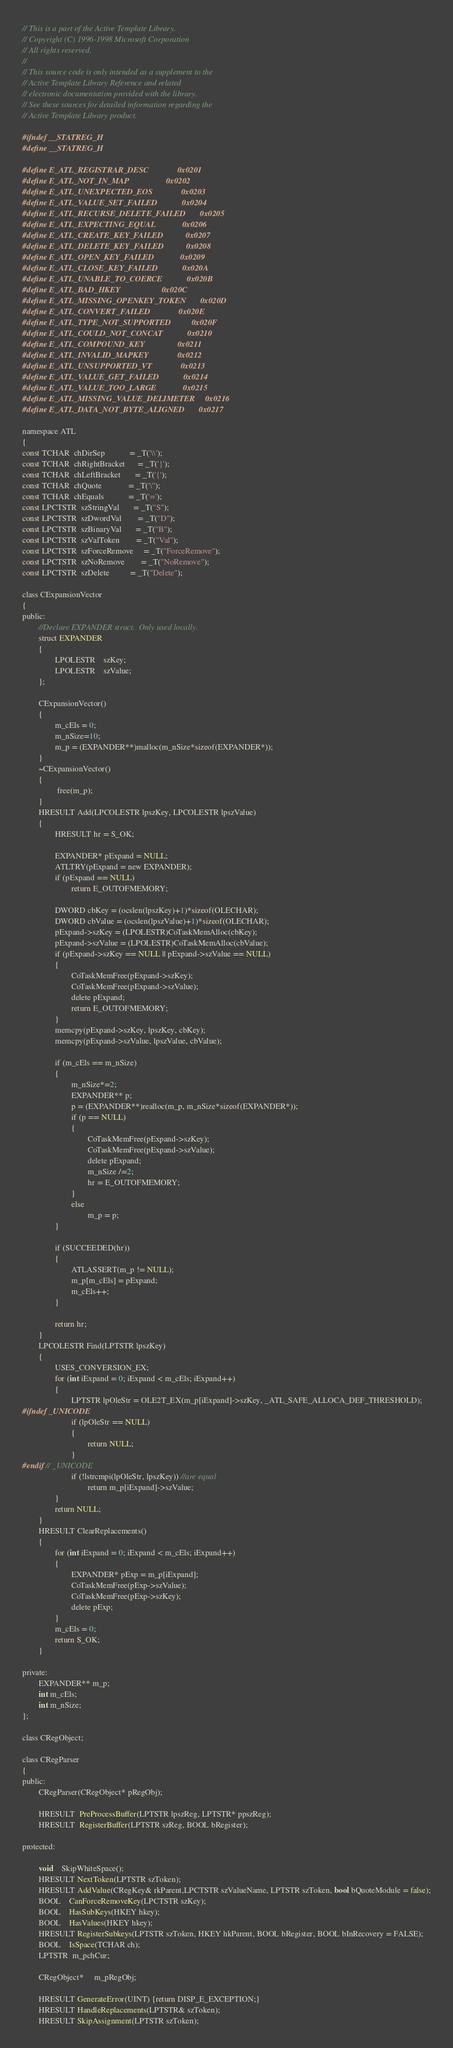Convert code to text. <code><loc_0><loc_0><loc_500><loc_500><_C_>// This is a part of the Active Template Library.
// Copyright (C) 1996-1998 Microsoft Corporation
// All rights reserved.
//
// This source code is only intended as a supplement to the
// Active Template Library Reference and related
// electronic documentation provided with the library.
// See these sources for detailed information regarding the
// Active Template Library product.

#ifndef __STATREG_H
#define __STATREG_H

#define E_ATL_REGISTRAR_DESC              0x0201
#define E_ATL_NOT_IN_MAP                  0x0202
#define E_ATL_UNEXPECTED_EOS              0x0203
#define E_ATL_VALUE_SET_FAILED            0x0204
#define E_ATL_RECURSE_DELETE_FAILED       0x0205
#define E_ATL_EXPECTING_EQUAL             0x0206
#define E_ATL_CREATE_KEY_FAILED           0x0207
#define E_ATL_DELETE_KEY_FAILED           0x0208
#define E_ATL_OPEN_KEY_FAILED             0x0209
#define E_ATL_CLOSE_KEY_FAILED            0x020A
#define E_ATL_UNABLE_TO_COERCE            0x020B
#define E_ATL_BAD_HKEY                    0x020C
#define E_ATL_MISSING_OPENKEY_TOKEN       0x020D
#define E_ATL_CONVERT_FAILED              0x020E
#define E_ATL_TYPE_NOT_SUPPORTED          0x020F
#define E_ATL_COULD_NOT_CONCAT            0x0210
#define E_ATL_COMPOUND_KEY                0x0211
#define E_ATL_INVALID_MAPKEY              0x0212
#define E_ATL_UNSUPPORTED_VT              0x0213
#define E_ATL_VALUE_GET_FAILED            0x0214
#define E_ATL_VALUE_TOO_LARGE             0x0215
#define E_ATL_MISSING_VALUE_DELIMETER     0x0216
#define E_ATL_DATA_NOT_BYTE_ALIGNED       0x0217

namespace ATL
{
const TCHAR  chDirSep            = _T('\\');
const TCHAR  chRightBracket      = _T('}');
const TCHAR  chLeftBracket       = _T('{');
const TCHAR  chQuote             = _T('\'');
const TCHAR  chEquals            = _T('=');
const LPCTSTR  szStringVal       = _T("S");
const LPCTSTR  szDwordVal        = _T("D");
const LPCTSTR  szBinaryVal       = _T("B");
const LPCTSTR  szValToken        = _T("Val");
const LPCTSTR  szForceRemove     = _T("ForceRemove");
const LPCTSTR  szNoRemove        = _T("NoRemove");
const LPCTSTR  szDelete          = _T("Delete");

class CExpansionVector
{
public:
        //Declare EXPANDER struct.  Only used locally.
        struct EXPANDER
        {
                LPOLESTR    szKey;
                LPOLESTR    szValue;
        };

        CExpansionVector()
        {
                m_cEls = 0;
                m_nSize=10;
                m_p = (EXPANDER**)malloc(m_nSize*sizeof(EXPANDER*));
        }
        ~CExpansionVector()
        {
                 free(m_p);
        }
        HRESULT Add(LPCOLESTR lpszKey, LPCOLESTR lpszValue)
        {
                HRESULT hr = S_OK;

                EXPANDER* pExpand = NULL;
                ATLTRY(pExpand = new EXPANDER);
                if (pExpand == NULL)
                        return E_OUTOFMEMORY;

                DWORD cbKey = (ocslen(lpszKey)+1)*sizeof(OLECHAR);
                DWORD cbValue = (ocslen(lpszValue)+1)*sizeof(OLECHAR);
                pExpand->szKey = (LPOLESTR)CoTaskMemAlloc(cbKey);
                pExpand->szValue = (LPOLESTR)CoTaskMemAlloc(cbValue);
                if (pExpand->szKey == NULL || pExpand->szValue == NULL)
                {
                        CoTaskMemFree(pExpand->szKey);
                        CoTaskMemFree(pExpand->szValue);
                        delete pExpand;
                        return E_OUTOFMEMORY;
                }
                memcpy(pExpand->szKey, lpszKey, cbKey);
                memcpy(pExpand->szValue, lpszValue, cbValue);

                if (m_cEls == m_nSize)
                {
                        m_nSize*=2;
                        EXPANDER** p;
                        p = (EXPANDER**)realloc(m_p, m_nSize*sizeof(EXPANDER*));
                        if (p == NULL)
                        {
                                CoTaskMemFree(pExpand->szKey);
                                CoTaskMemFree(pExpand->szValue);
                                delete pExpand;
                                m_nSize /=2;
                                hr = E_OUTOFMEMORY;
                        }
                        else
                                m_p = p;
                }

                if (SUCCEEDED(hr))
                {
                        ATLASSERT(m_p != NULL);
                        m_p[m_cEls] = pExpand;
                        m_cEls++;
                }

                return hr;
        }
        LPCOLESTR Find(LPTSTR lpszKey)
        {
                USES_CONVERSION_EX;
                for (int iExpand = 0; iExpand < m_cEls; iExpand++)
                {
                        LPTSTR lpOleStr = OLE2T_EX(m_p[iExpand]->szKey, _ATL_SAFE_ALLOCA_DEF_THRESHOLD);
#ifndef _UNICODE
                        if (lpOleStr == NULL)
                        {
                                return NULL;
                        }
#endif // _UNICODE
                        if (!lstrcmpi(lpOleStr, lpszKey)) //are equal
                                return m_p[iExpand]->szValue;
                }
                return NULL;
        }
        HRESULT ClearReplacements()
        {
                for (int iExpand = 0; iExpand < m_cEls; iExpand++)
                {
                        EXPANDER* pExp = m_p[iExpand];
                        CoTaskMemFree(pExp->szValue);
                        CoTaskMemFree(pExp->szKey);
                        delete pExp;
                }
                m_cEls = 0;
                return S_OK;
        }

private:
        EXPANDER** m_p;
        int m_cEls;
        int m_nSize;
};

class CRegObject;

class CRegParser
{
public:
        CRegParser(CRegObject* pRegObj);

        HRESULT  PreProcessBuffer(LPTSTR lpszReg, LPTSTR* ppszReg);
        HRESULT  RegisterBuffer(LPTSTR szReg, BOOL bRegister);

protected:

        void    SkipWhiteSpace();
        HRESULT NextToken(LPTSTR szToken);
        HRESULT AddValue(CRegKey& rkParent,LPCTSTR szValueName, LPTSTR szToken, bool bQuoteModule = false);
        BOOL    CanForceRemoveKey(LPCTSTR szKey);
        BOOL    HasSubKeys(HKEY hkey);
        BOOL    HasValues(HKEY hkey);
        HRESULT RegisterSubkeys(LPTSTR szToken, HKEY hkParent, BOOL bRegister, BOOL bInRecovery = FALSE);
        BOOL    IsSpace(TCHAR ch);
        LPTSTR  m_pchCur;

        CRegObject*     m_pRegObj;

        HRESULT GenerateError(UINT) {return DISP_E_EXCEPTION;}
        HRESULT HandleReplacements(LPTSTR& szToken);
        HRESULT SkipAssignment(LPTSTR szToken);
</code> 